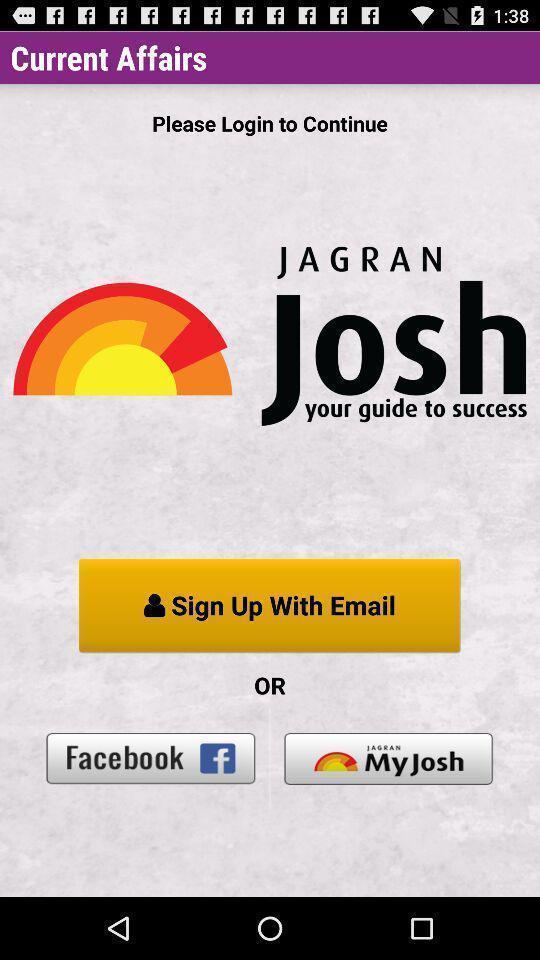Summarize the main components in this picture. Welcome page. 